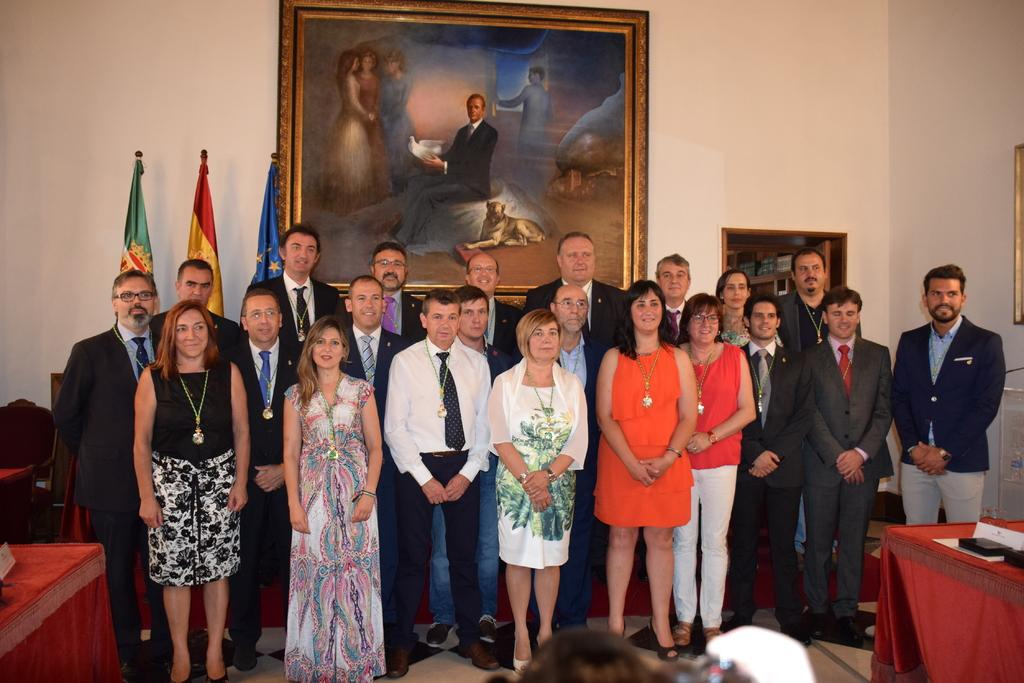What are the people in the image doing? The people in the image are standing and posing for a photo. What can be seen on the wall in the image? There is a photo frame on the wall in the image. What is visible in the background of the image? There are three flags in the background of the image. What type of plot is being discussed by the people in the image? There is no indication in the image that the people are discussing a plot, as they are posing for a photo. What drug is being used by the people in the image? There is no indication in the image that any drugs are being used, as the people are posing for a photo. 